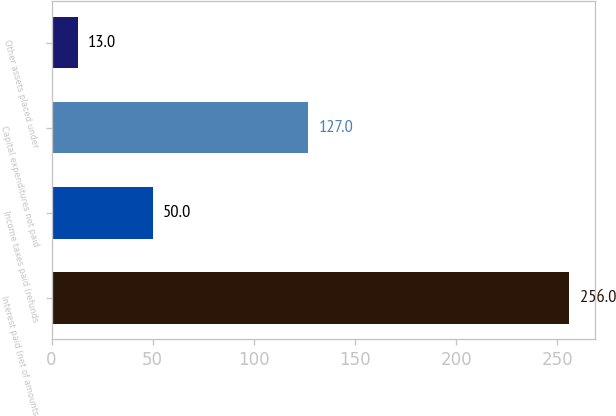Convert chart to OTSL. <chart><loc_0><loc_0><loc_500><loc_500><bar_chart><fcel>Interest paid (net of amounts<fcel>Income taxes paid (refunds<fcel>Capital expenditures not paid<fcel>Other assets placed under<nl><fcel>256<fcel>50<fcel>127<fcel>13<nl></chart> 